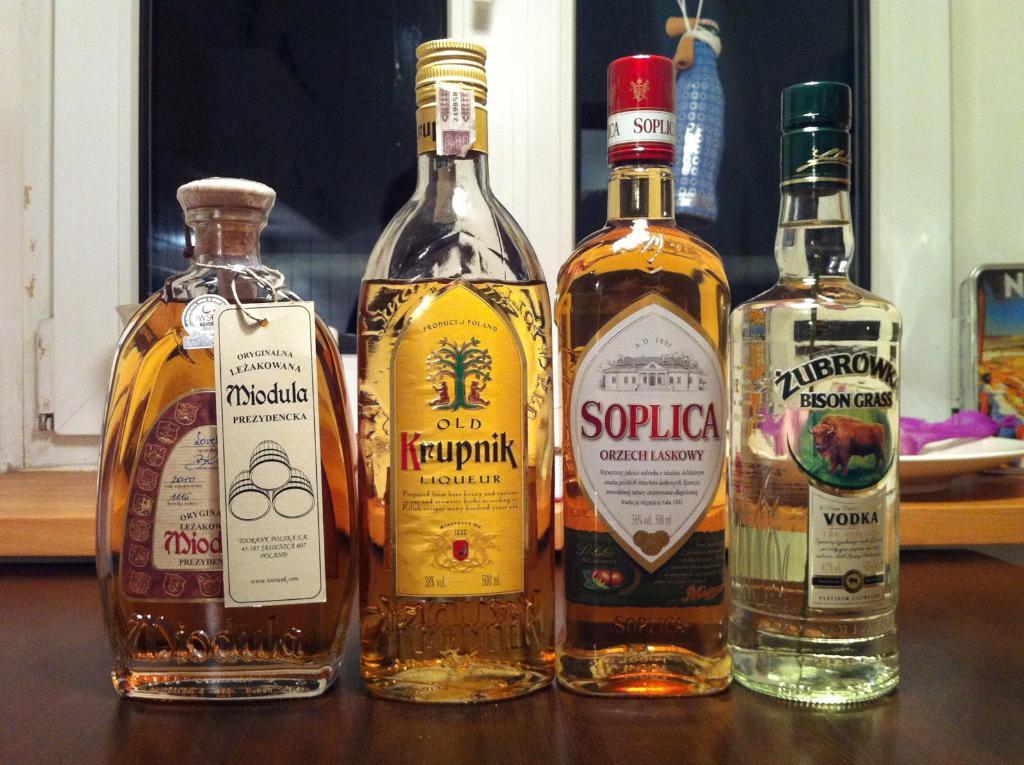What brand is the 3rd bottle starting from the left?
Give a very brief answer. Soplica. 